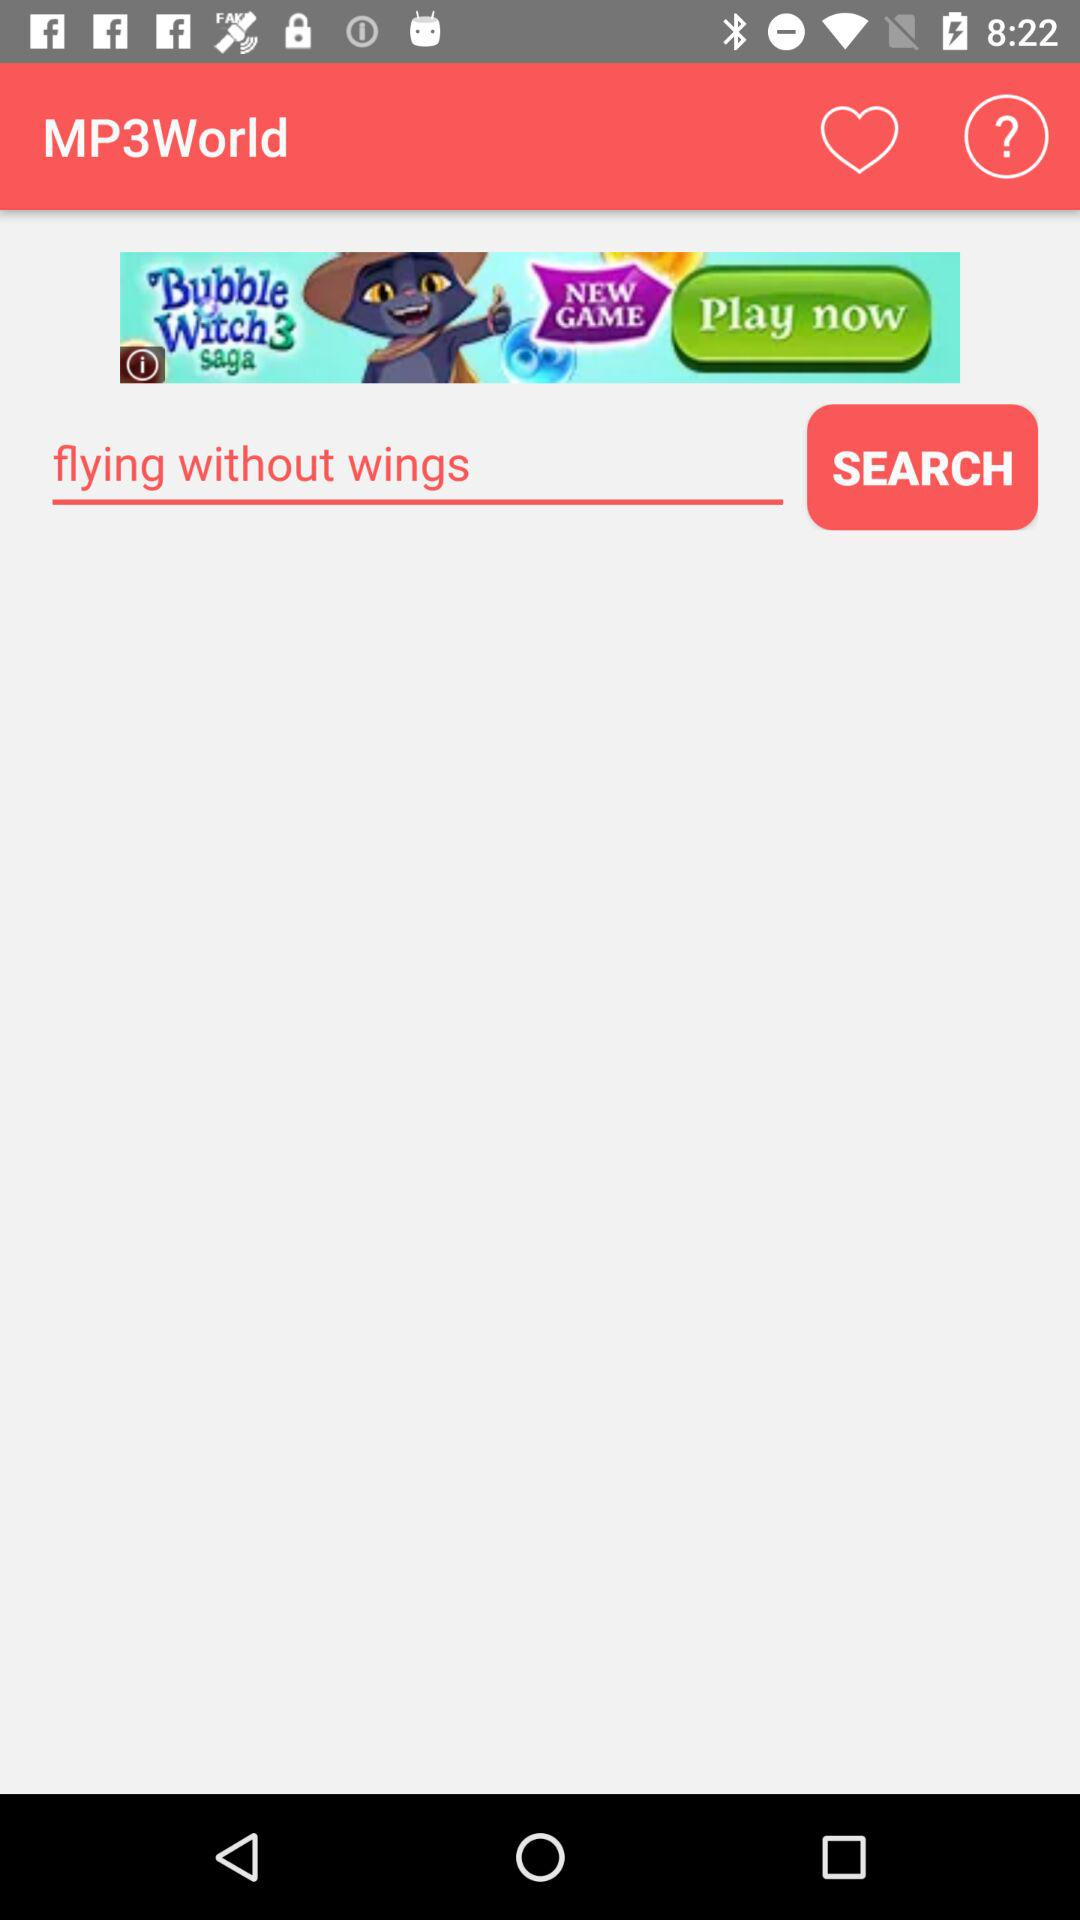What is the application name? The application name is "MP3World". 